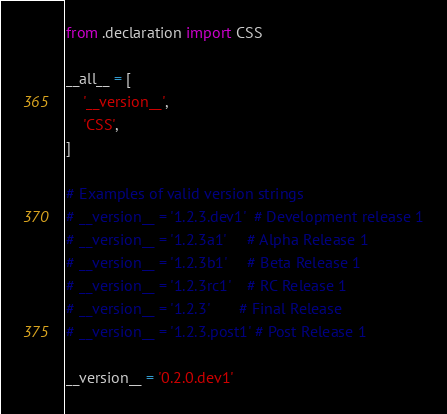Convert code to text. <code><loc_0><loc_0><loc_500><loc_500><_Python_>from .declaration import CSS

__all__ = [
    '__version__',
    'CSS',
]

# Examples of valid version strings
# __version__ = '1.2.3.dev1'  # Development release 1
# __version__ = '1.2.3a1'     # Alpha Release 1
# __version__ = '1.2.3b1'     # Beta Release 1
# __version__ = '1.2.3rc1'    # RC Release 1
# __version__ = '1.2.3'       # Final Release
# __version__ = '1.2.3.post1' # Post Release 1

__version__ = '0.2.0.dev1'
</code> 